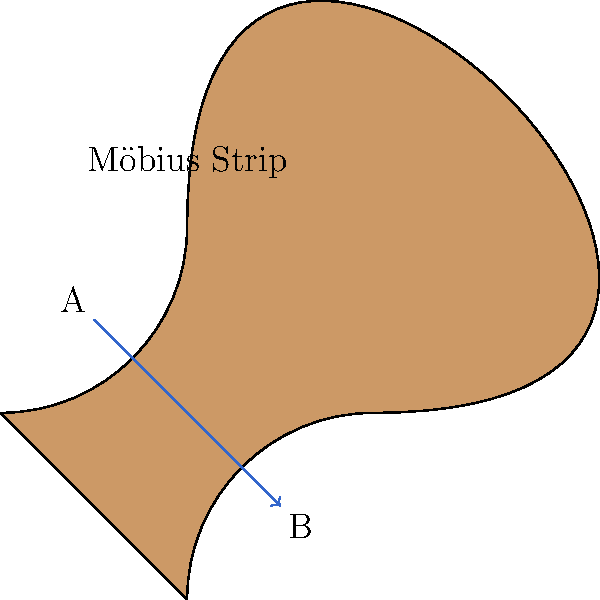In the context of Non-Euclidean geometry, consider a Möbius strip as shown in the diagram. If a writer were to trace a path along the surface from point A to point B, how would the orientation of their writing change, and what does this reveal about the strip's non-orientable properties? Relate this to the chemical process of fermentation, where molecules undergo transformations that can be visualized as topological changes. To understand this problem, let's break it down step-by-step:

1) A Möbius strip is a non-orientable surface, meaning it has only one side and one edge.

2) As the writer traces a path from A to B:
   a) They start on what seems to be the "top" surface.
   b) Following the path, they will end up on what appears to be the "bottom" surface at point B.
   c) However, they never crossed an edge, implying the strip has only one surface.

3) The orientation of the writing will be inverted (upside-down) when reaching point B, compared to its orientation at point A.

4) This change in orientation without crossing an edge demonstrates the non-orientable property of the Möbius strip.

5) In Non-Euclidean geometry, this property challenges our intuition about orientation and dimensionality.

6) Relating to fermentation:
   a) During fermentation, molecules undergo complex transformations.
   b) These transformations can be visualized as topological changes, similar to the path on a Möbius strip.
   c) Just as the writer's path leads to an unexpected orientation, molecules in fermentation may end up in configurations that are not intuitively predictable from their starting state.

7) The non-orientable nature of the Möbius strip serves as a metaphor for the complex, often counterintuitive changes that occur at the molecular level during fermentation.

This visualization helps in understanding both the abstract concept of non-orientability in Non-Euclidean geometry and the complex molecular transformations in fermentation processes.
Answer: The writing orientation inverts, revealing the strip's non-orientable, single-surface nature, analogous to counterintuitive molecular transformations in fermentation. 